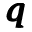<formula> <loc_0><loc_0><loc_500><loc_500>\pm b q</formula> 